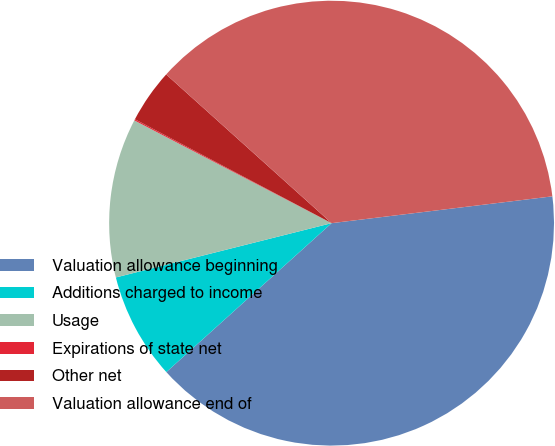Convert chart. <chart><loc_0><loc_0><loc_500><loc_500><pie_chart><fcel>Valuation allowance beginning<fcel>Additions charged to income<fcel>Usage<fcel>Expirations of state net<fcel>Other net<fcel>Valuation allowance end of<nl><fcel>40.25%<fcel>7.75%<fcel>11.57%<fcel>0.09%<fcel>3.92%<fcel>36.42%<nl></chart> 